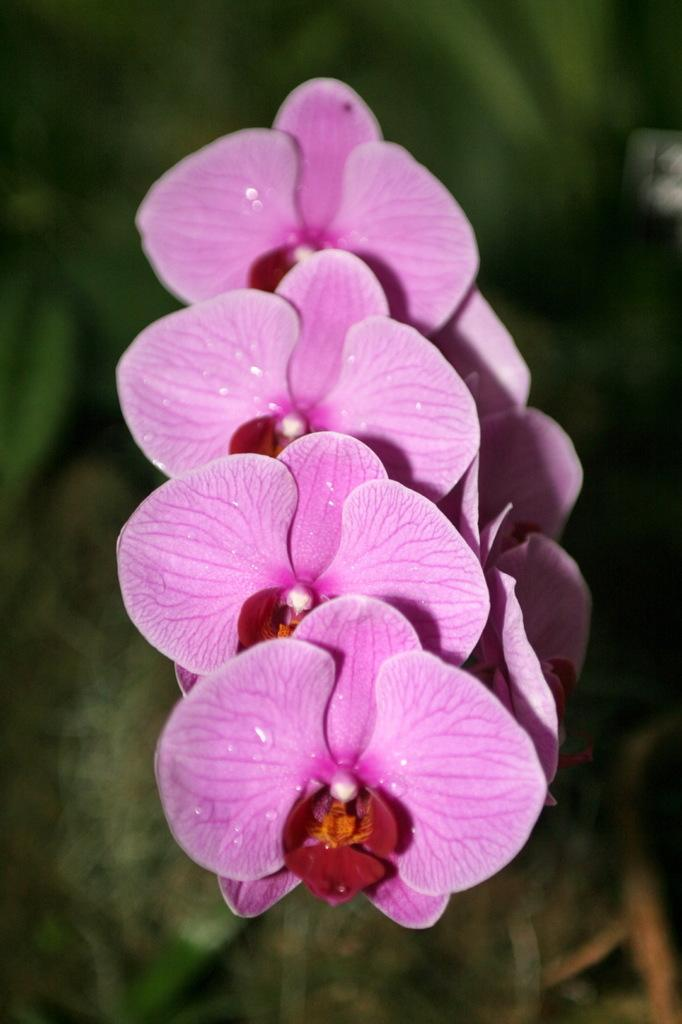What type of flower is in the image? There is a pink color flower in the image. Can you describe the background of the image? The background of the image is blurred. Where is the ant located in the image? There is no ant present in the image. Can you see a volcano in the background of the image? There is no volcano present in the image. 